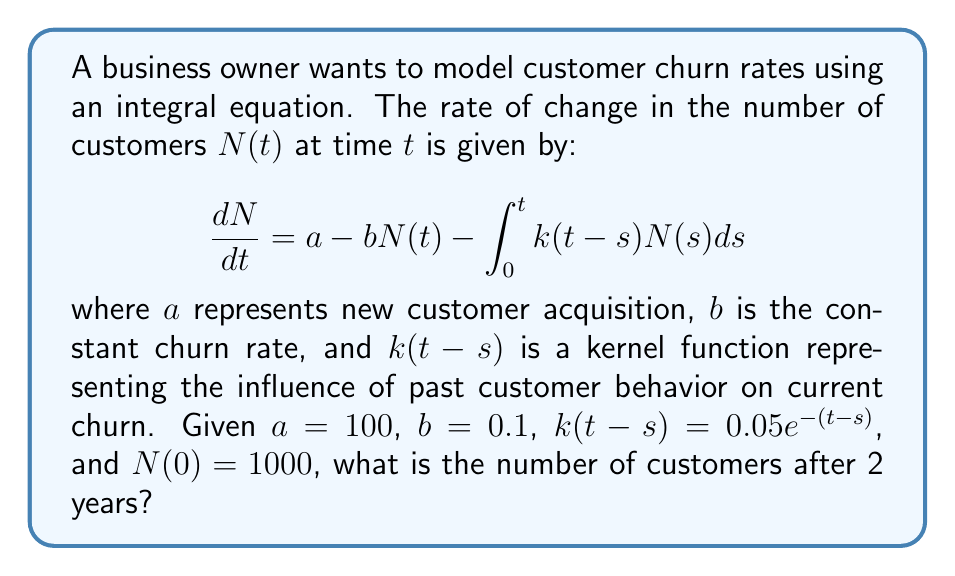Can you answer this question? To solve this problem, we need to follow these steps:

1) First, we recognize this as a Volterra integral equation of the second kind. The general form is:

   $$N(t) = f(t) + \int_0^t K(t,s)N(s)ds$$

2) In our case, we need to transform our equation into this form. We start by integrating both sides:

   $$N(t) = N(0) + \int_0^t [a - bN(s) - \int_0^s k(s-u)N(u)du]ds$$

3) Rearranging terms:

   $$N(t) = N(0) + at - b\int_0^t N(s)ds - \int_0^t \int_0^s k(s-u)N(u)du ds$$

4) Changing the order of integration in the double integral:

   $$N(t) = N(0) + at - b\int_0^t N(s)ds - \int_0^t \int_u^t k(s-u)ds N(u)du$$

5) Evaluating the inner integral:

   $$\int_u^t k(s-u)ds = \int_u^t 0.05e^{-(s-u)}ds = 0.05[1-e^{-(t-u)}]$$

6) Substituting back:

   $$N(t) = 1000 + 100t - 0.1\int_0^t N(s)ds - \int_0^t 0.05[1-e^{-(t-u)}]N(u)du$$

7) This is now in the form of a Volterra equation. While exact solutions are generally difficult, we can use numerical methods to approximate the solution.

8) Using a numerical solver (like Runge-Kutta method or Picard iteration), we can approximate $N(2)$ (as t=2 represents 2 years).

9) The approximate solution after 2 years is $N(2) \approx 1428$ customers.
Answer: $N(2) \approx 1428$ customers 